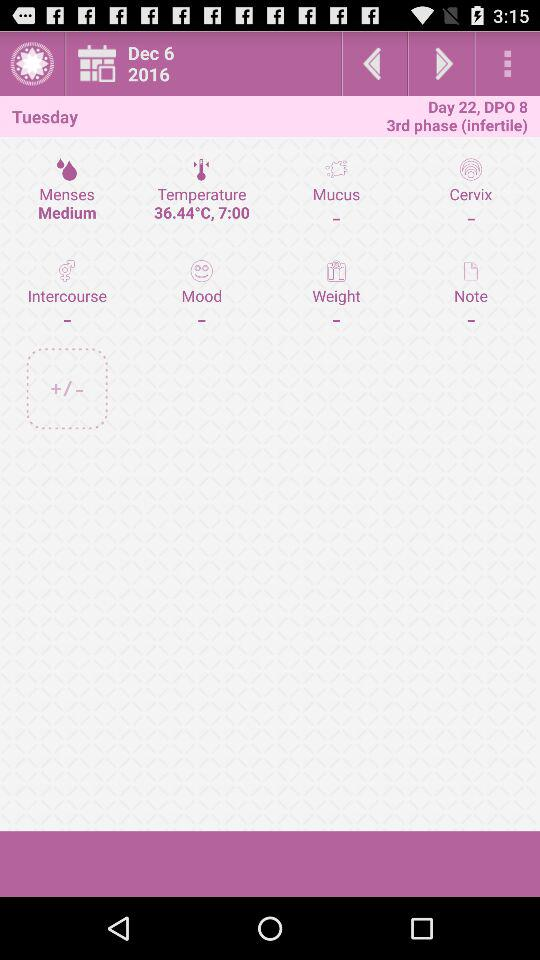What is the measured temperature value? The measured temperature value is 36.44 °C. 